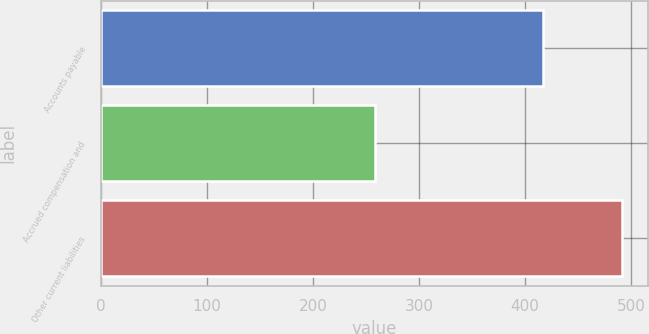Convert chart to OTSL. <chart><loc_0><loc_0><loc_500><loc_500><bar_chart><fcel>Accounts payable<fcel>Accrued compensation and<fcel>Other current liabilities<nl><fcel>417<fcel>258<fcel>491<nl></chart> 